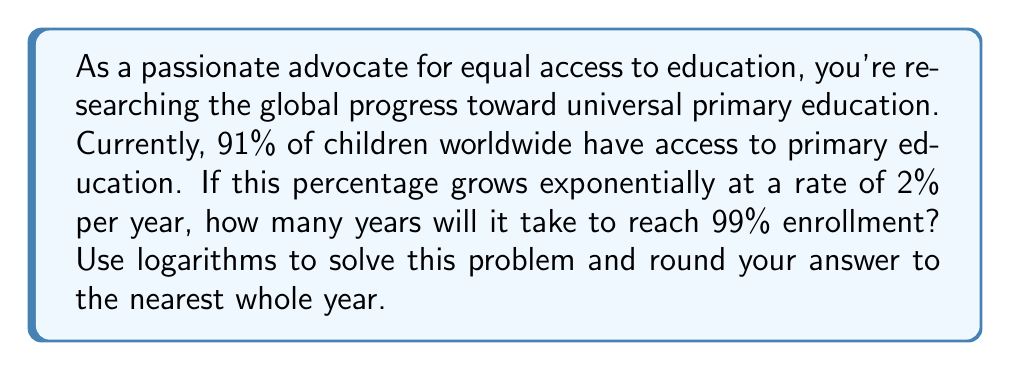Can you answer this question? To solve this problem, we'll use the exponential growth formula and logarithms. Let's break it down step-by-step:

1) The exponential growth formula is:
   $$ A = P(1 + r)^t $$
   Where:
   $A$ is the final amount
   $P$ is the initial amount
   $r$ is the growth rate (as a decimal)
   $t$ is the time in years

2) In this case:
   $P = 0.91$ (91% initial enrollment)
   $r = 0.02$ (2% growth rate)
   $A = 0.99$ (99% target enrollment)

3) Plugging these into the formula:
   $$ 0.99 = 0.91(1 + 0.02)^t $$

4) Simplify:
   $$ 0.99 = 0.91(1.02)^t $$

5) Divide both sides by 0.91:
   $$ \frac{0.99}{0.91} = (1.02)^t $$

6) Take the natural log of both sides:
   $$ \ln(\frac{0.99}{0.91}) = \ln((1.02)^t) $$

7) Using the logarithm property $\ln(a^b) = b\ln(a)$:
   $$ \ln(\frac{0.99}{0.91}) = t\ln(1.02) $$

8) Solve for $t$:
   $$ t = \frac{\ln(\frac{0.99}{0.91})}{\ln(1.02)} $$

9) Calculate:
   $$ t = \frac{\ln(1.087912088)}{0.019802627} \approx 4.27 $$

10) Rounding to the nearest whole year:
    $t \approx 4$ years
Answer: It will take approximately 4 years to reach 99% enrollment in primary education worldwide, given the current conditions and growth rate. 